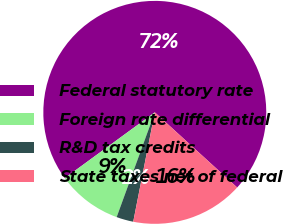<chart> <loc_0><loc_0><loc_500><loc_500><pie_chart><fcel>Federal statutory rate<fcel>Foreign rate differential<fcel>R&D tax credits<fcel>State taxes net of federal<nl><fcel>71.81%<fcel>9.4%<fcel>2.46%<fcel>16.33%<nl></chart> 